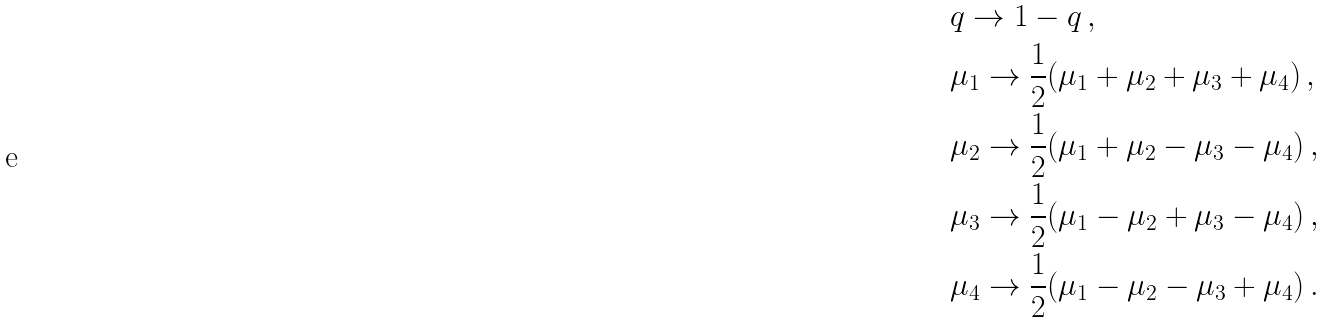<formula> <loc_0><loc_0><loc_500><loc_500>& q \to 1 - q \, , \\ & \mu _ { 1 } \to \frac { 1 } { 2 } ( \mu _ { 1 } + \mu _ { 2 } + \mu _ { 3 } + \mu _ { 4 } ) \, , \\ & \mu _ { 2 } \to \frac { 1 } { 2 } ( \mu _ { 1 } + \mu _ { 2 } - \mu _ { 3 } - \mu _ { 4 } ) \, , \\ & \mu _ { 3 } \to \frac { 1 } { 2 } ( \mu _ { 1 } - \mu _ { 2 } + \mu _ { 3 } - \mu _ { 4 } ) \, , \\ & \mu _ { 4 } \to \frac { 1 } { 2 } ( \mu _ { 1 } - \mu _ { 2 } - \mu _ { 3 } + \mu _ { 4 } ) \, .</formula> 